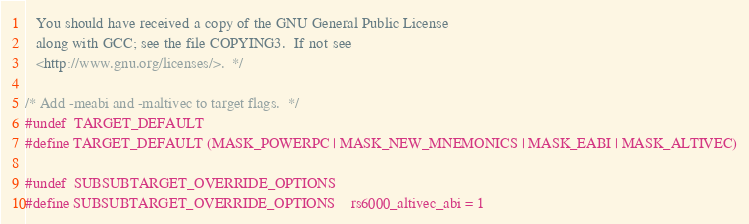<code> <loc_0><loc_0><loc_500><loc_500><_C_>
   You should have received a copy of the GNU General Public License
   along with GCC; see the file COPYING3.  If not see
   <http://www.gnu.org/licenses/>.  */

/* Add -meabi and -maltivec to target flags.  */
#undef  TARGET_DEFAULT
#define TARGET_DEFAULT (MASK_POWERPC | MASK_NEW_MNEMONICS | MASK_EABI | MASK_ALTIVEC)

#undef  SUBSUBTARGET_OVERRIDE_OPTIONS
#define SUBSUBTARGET_OVERRIDE_OPTIONS	rs6000_altivec_abi = 1
</code> 